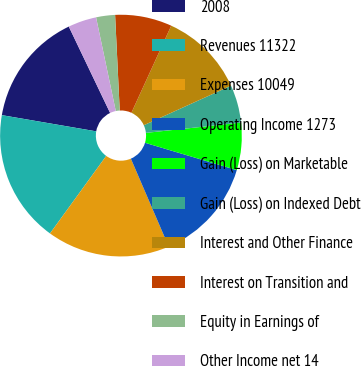Convert chart. <chart><loc_0><loc_0><loc_500><loc_500><pie_chart><fcel>2008<fcel>Revenues 11322<fcel>Expenses 10049<fcel>Operating Income 1273<fcel>Gain (Loss) on Marketable<fcel>Gain (Loss) on Indexed Debt<fcel>Interest and Other Finance<fcel>Interest on Transition and<fcel>Equity in Earnings of<fcel>Other Income net 14<nl><fcel>15.19%<fcel>17.72%<fcel>16.45%<fcel>13.92%<fcel>6.33%<fcel>5.06%<fcel>11.39%<fcel>7.6%<fcel>2.53%<fcel>3.8%<nl></chart> 